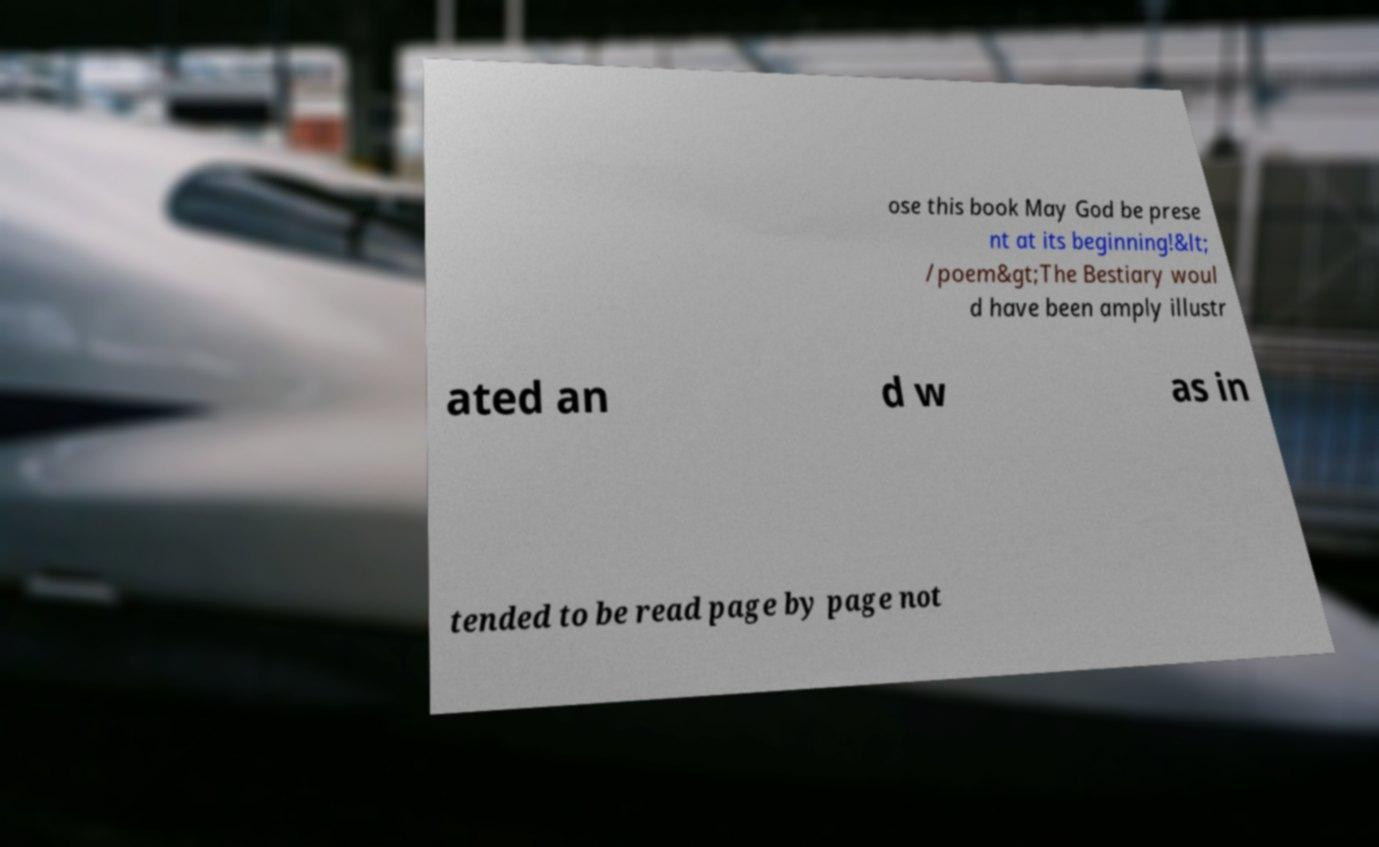I need the written content from this picture converted into text. Can you do that? ose this book May God be prese nt at its beginning!&lt; /poem&gt;The Bestiary woul d have been amply illustr ated an d w as in tended to be read page by page not 